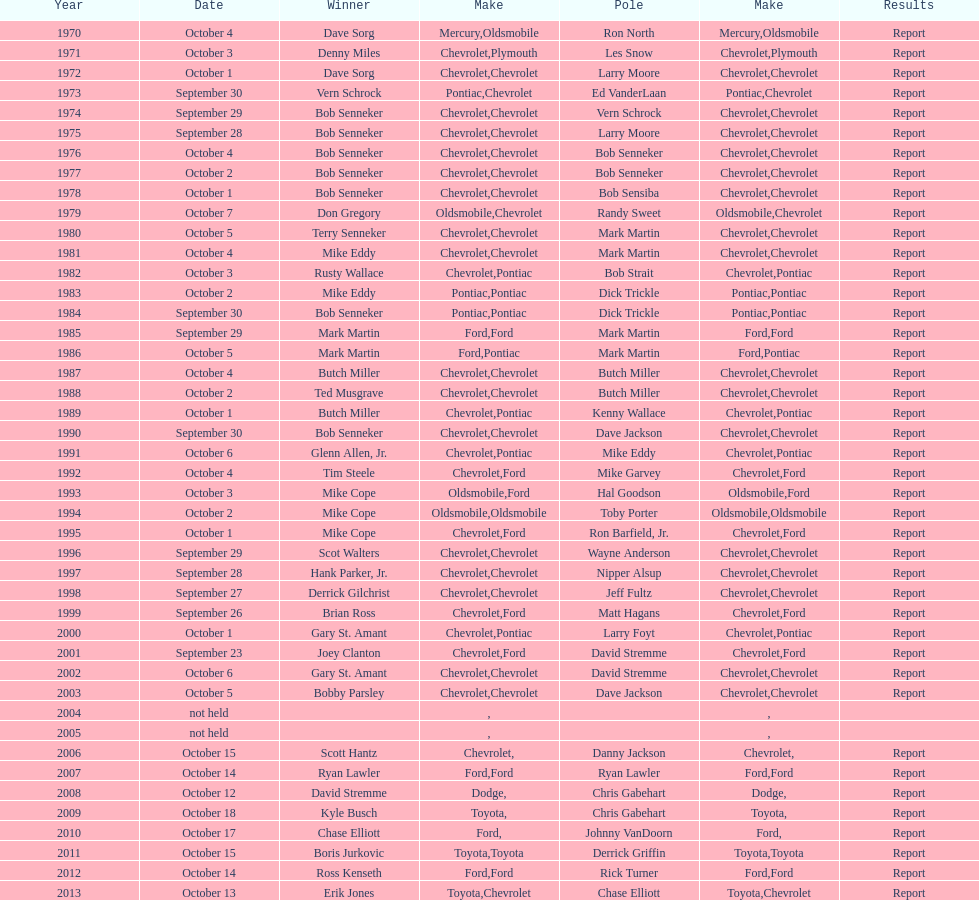During which month did the majority of winchester 400 races take place? October. 